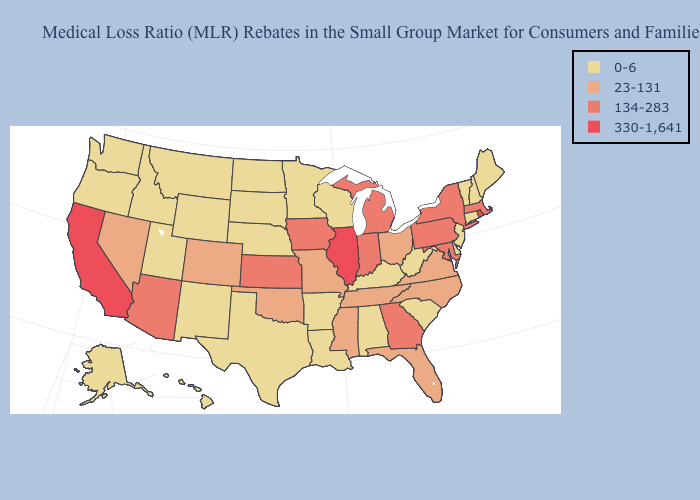Among the states that border California , which have the lowest value?
Give a very brief answer. Oregon. Name the states that have a value in the range 0-6?
Be succinct. Alabama, Alaska, Arkansas, Connecticut, Delaware, Hawaii, Idaho, Kentucky, Louisiana, Maine, Minnesota, Montana, Nebraska, New Hampshire, New Jersey, New Mexico, North Dakota, Oregon, South Carolina, South Dakota, Texas, Utah, Vermont, Washington, West Virginia, Wisconsin, Wyoming. Does Hawaii have a higher value than Massachusetts?
Concise answer only. No. Name the states that have a value in the range 23-131?
Quick response, please. Colorado, Florida, Mississippi, Missouri, Nevada, North Carolina, Ohio, Oklahoma, Tennessee, Virginia. Does Alaska have the highest value in the West?
Answer briefly. No. How many symbols are there in the legend?
Give a very brief answer. 4. Name the states that have a value in the range 134-283?
Concise answer only. Arizona, Georgia, Indiana, Iowa, Kansas, Maryland, Massachusetts, Michigan, New York, Pennsylvania. What is the value of Massachusetts?
Be succinct. 134-283. Name the states that have a value in the range 134-283?
Answer briefly. Arizona, Georgia, Indiana, Iowa, Kansas, Maryland, Massachusetts, Michigan, New York, Pennsylvania. What is the lowest value in the West?
Be succinct. 0-6. Name the states that have a value in the range 23-131?
Keep it brief. Colorado, Florida, Mississippi, Missouri, Nevada, North Carolina, Ohio, Oklahoma, Tennessee, Virginia. What is the value of Iowa?
Short answer required. 134-283. Does Alaska have the highest value in the West?
Concise answer only. No. Name the states that have a value in the range 330-1,641?
Write a very short answer. California, Illinois, Rhode Island. 